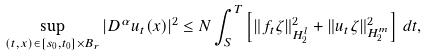<formula> <loc_0><loc_0><loc_500><loc_500>\sup _ { ( t , x ) \in [ s _ { 0 } , t _ { 0 } ] \times B _ { r } } | D ^ { \alpha } u _ { t } ( x ) | ^ { 2 } \leq N \int _ { S } ^ { T } \left [ \| f _ { t } \zeta \| _ { H ^ { l } _ { 2 } } ^ { 2 } + \| u _ { t } \zeta \| _ { H ^ { m } _ { 2 } } ^ { 2 } \right ] \, d t ,</formula> 